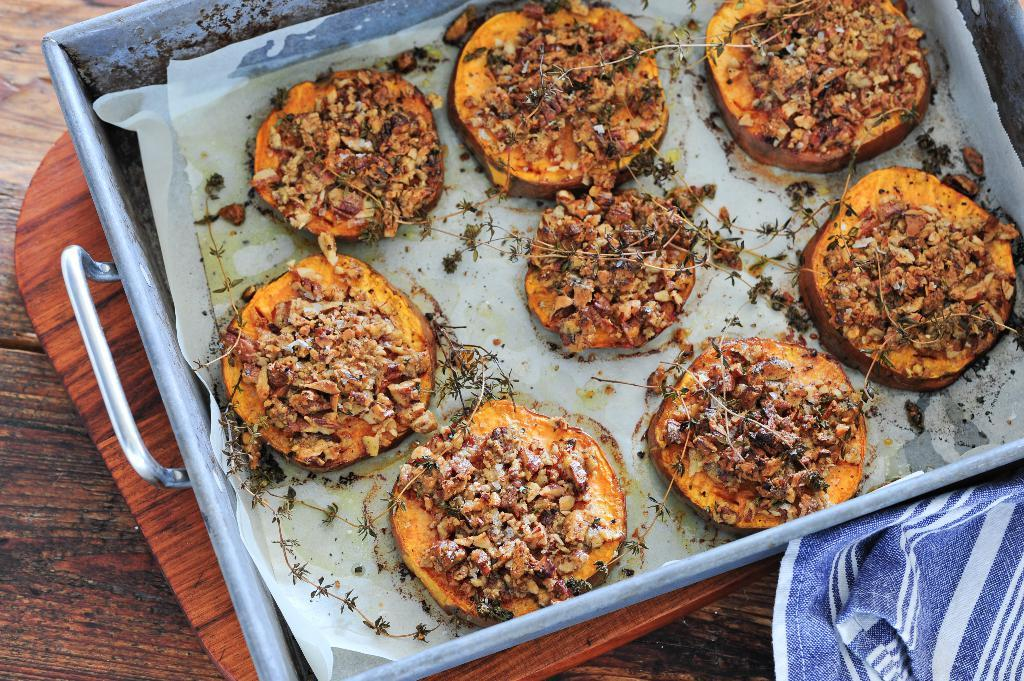What type of food items can be seen in the image? There are cooked food items in the image. How are the food items arranged in the image? The food items are in a tray. What is the tray placed on in the image? The tray is kept on a wooden table. Can you see any grass growing on the wooden table in the image? No, there is no grass visible in the image; the tray with food items is placed on a wooden table. 